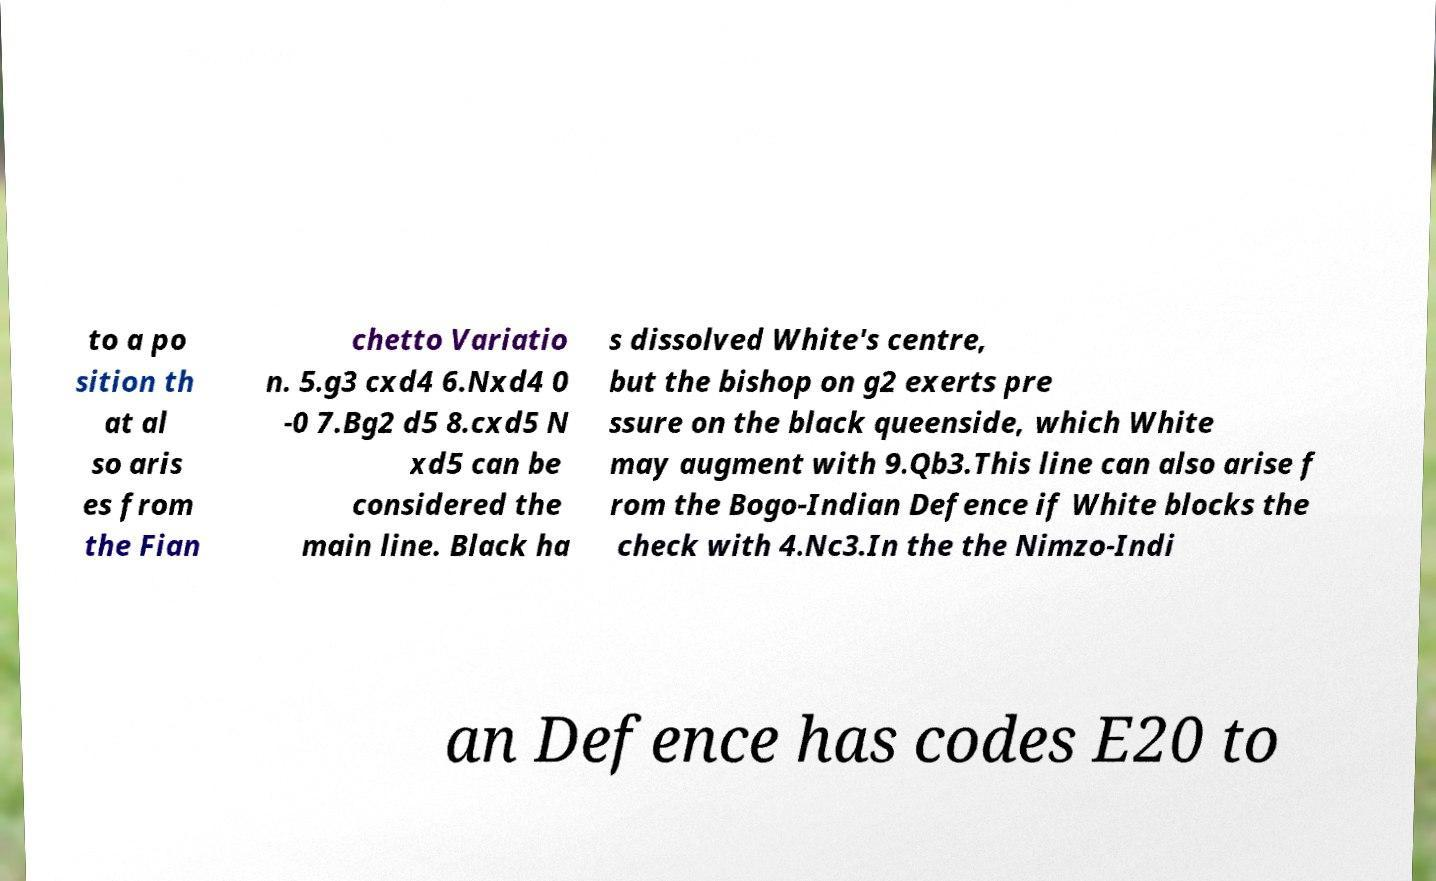What messages or text are displayed in this image? I need them in a readable, typed format. to a po sition th at al so aris es from the Fian chetto Variatio n. 5.g3 cxd4 6.Nxd4 0 -0 7.Bg2 d5 8.cxd5 N xd5 can be considered the main line. Black ha s dissolved White's centre, but the bishop on g2 exerts pre ssure on the black queenside, which White may augment with 9.Qb3.This line can also arise f rom the Bogo-Indian Defence if White blocks the check with 4.Nc3.In the the Nimzo-Indi an Defence has codes E20 to 